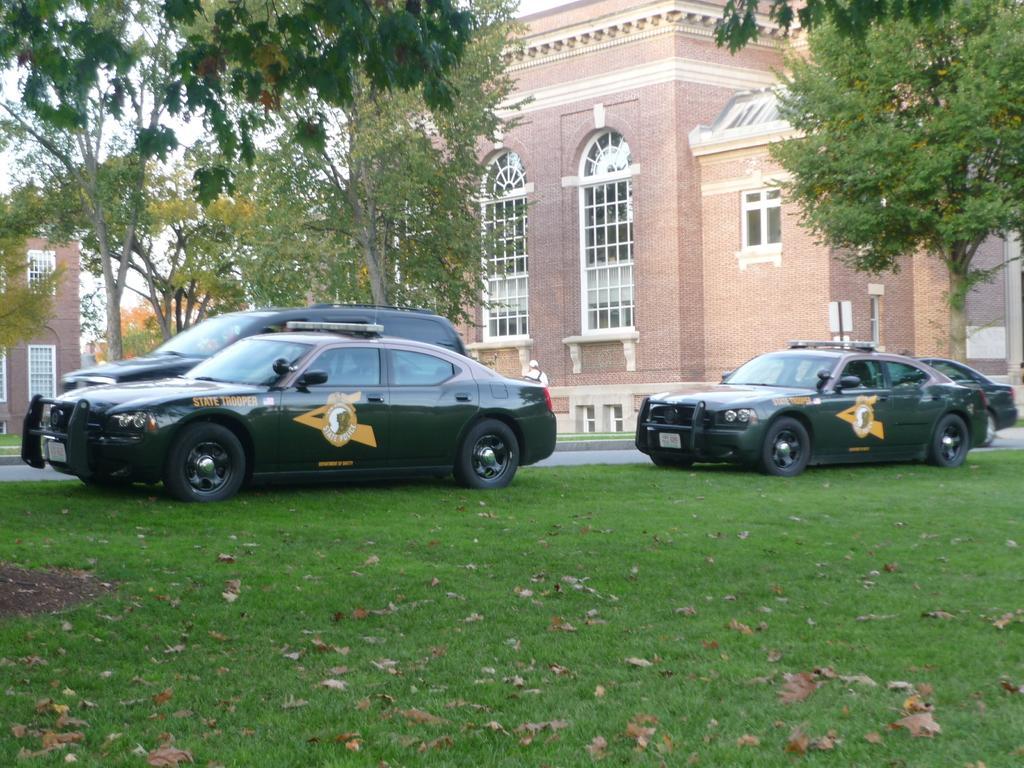Describe this image in one or two sentences. In the picture there are four different cars parked in front of a building and beside the cars there are some trees and grass. 